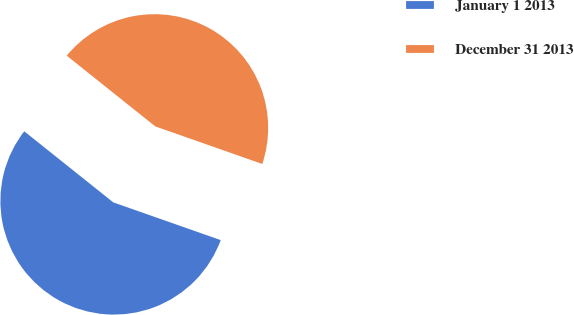Convert chart. <chart><loc_0><loc_0><loc_500><loc_500><pie_chart><fcel>January 1 2013<fcel>December 31 2013<nl><fcel>55.35%<fcel>44.65%<nl></chart> 